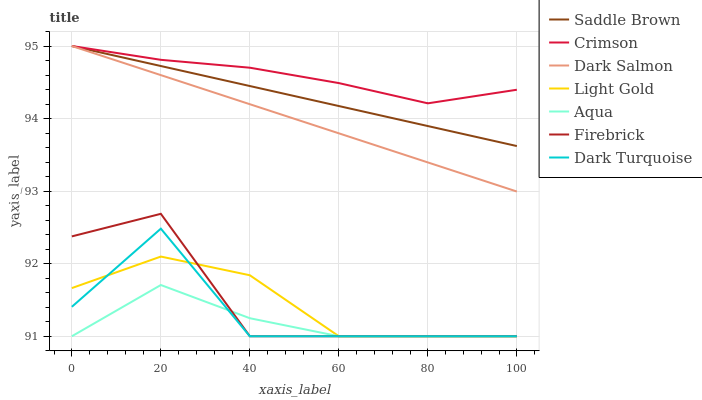Does Firebrick have the minimum area under the curve?
Answer yes or no. No. Does Firebrick have the maximum area under the curve?
Answer yes or no. No. Is Firebrick the smoothest?
Answer yes or no. No. Is Firebrick the roughest?
Answer yes or no. No. Does Dark Salmon have the lowest value?
Answer yes or no. No. Does Firebrick have the highest value?
Answer yes or no. No. Is Firebrick less than Crimson?
Answer yes or no. Yes. Is Saddle Brown greater than Firebrick?
Answer yes or no. Yes. Does Firebrick intersect Crimson?
Answer yes or no. No. 